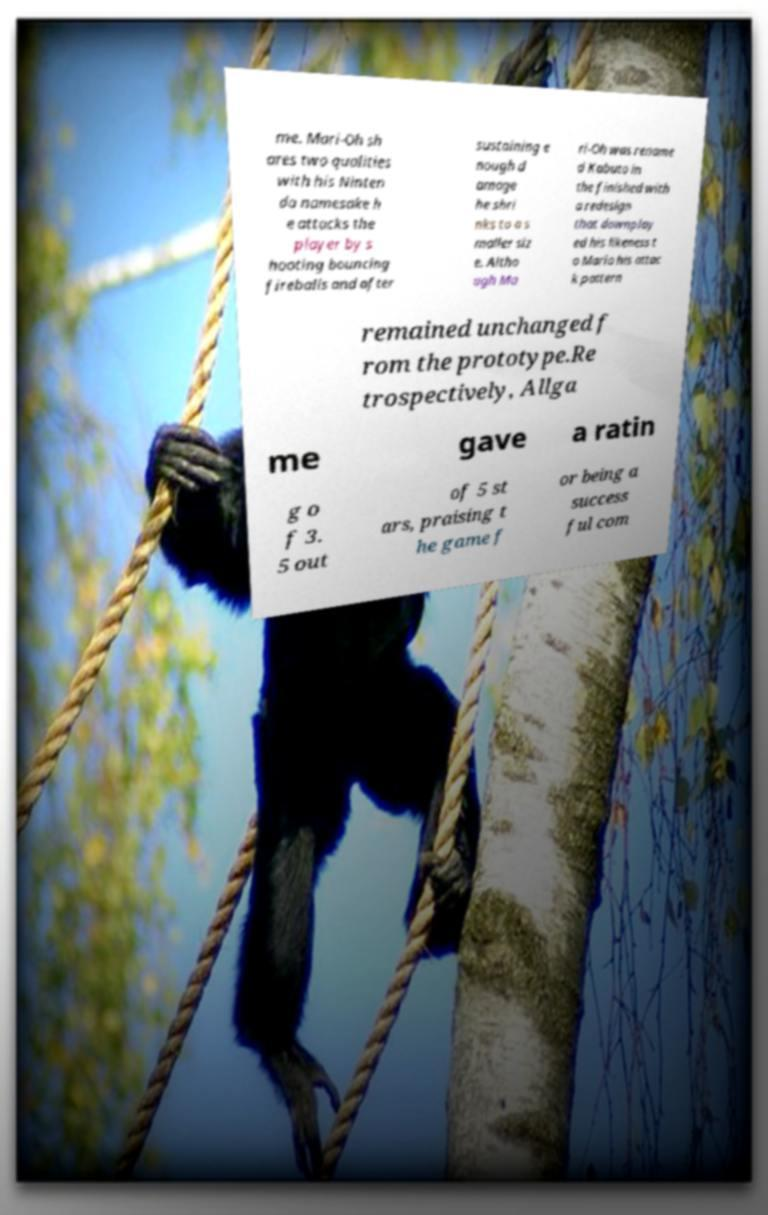Can you read and provide the text displayed in the image?This photo seems to have some interesting text. Can you extract and type it out for me? me. Mari-Oh sh ares two qualities with his Ninten do namesake h e attacks the player by s hooting bouncing fireballs and after sustaining e nough d amage he shri nks to a s maller siz e. Altho ugh Ma ri-Oh was rename d Kabuto in the finished with a redesign that downplay ed his likeness t o Mario his attac k pattern remained unchanged f rom the prototype.Re trospectively, Allga me gave a ratin g o f 3. 5 out of 5 st ars, praising t he game f or being a success ful com 